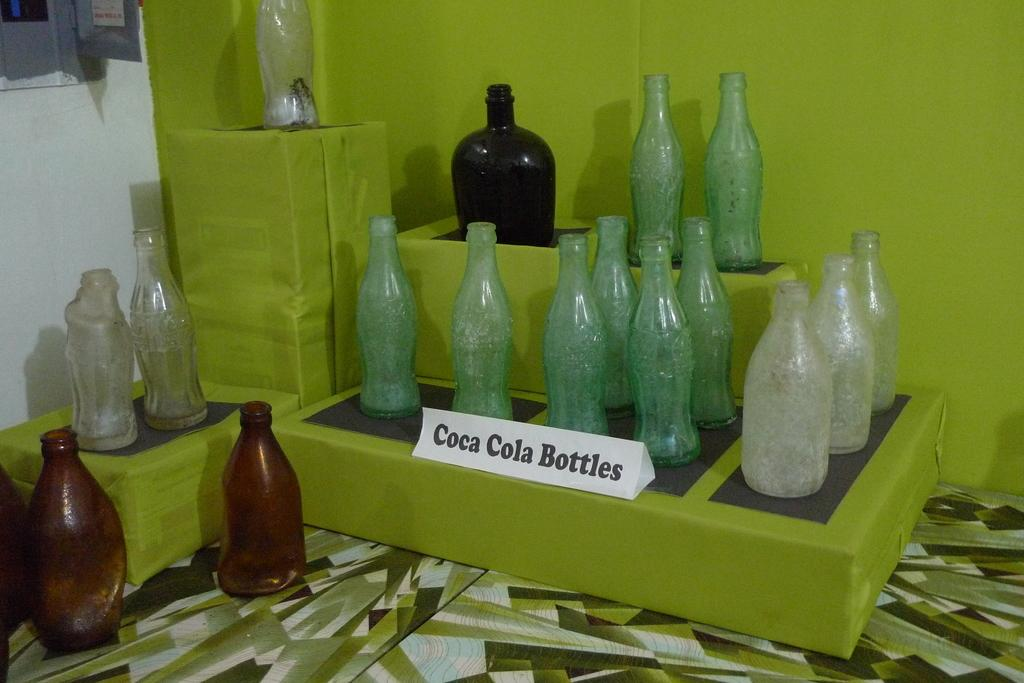<image>
Render a clear and concise summary of the photo. A display of empty coca cola bottles arranged artistically. 